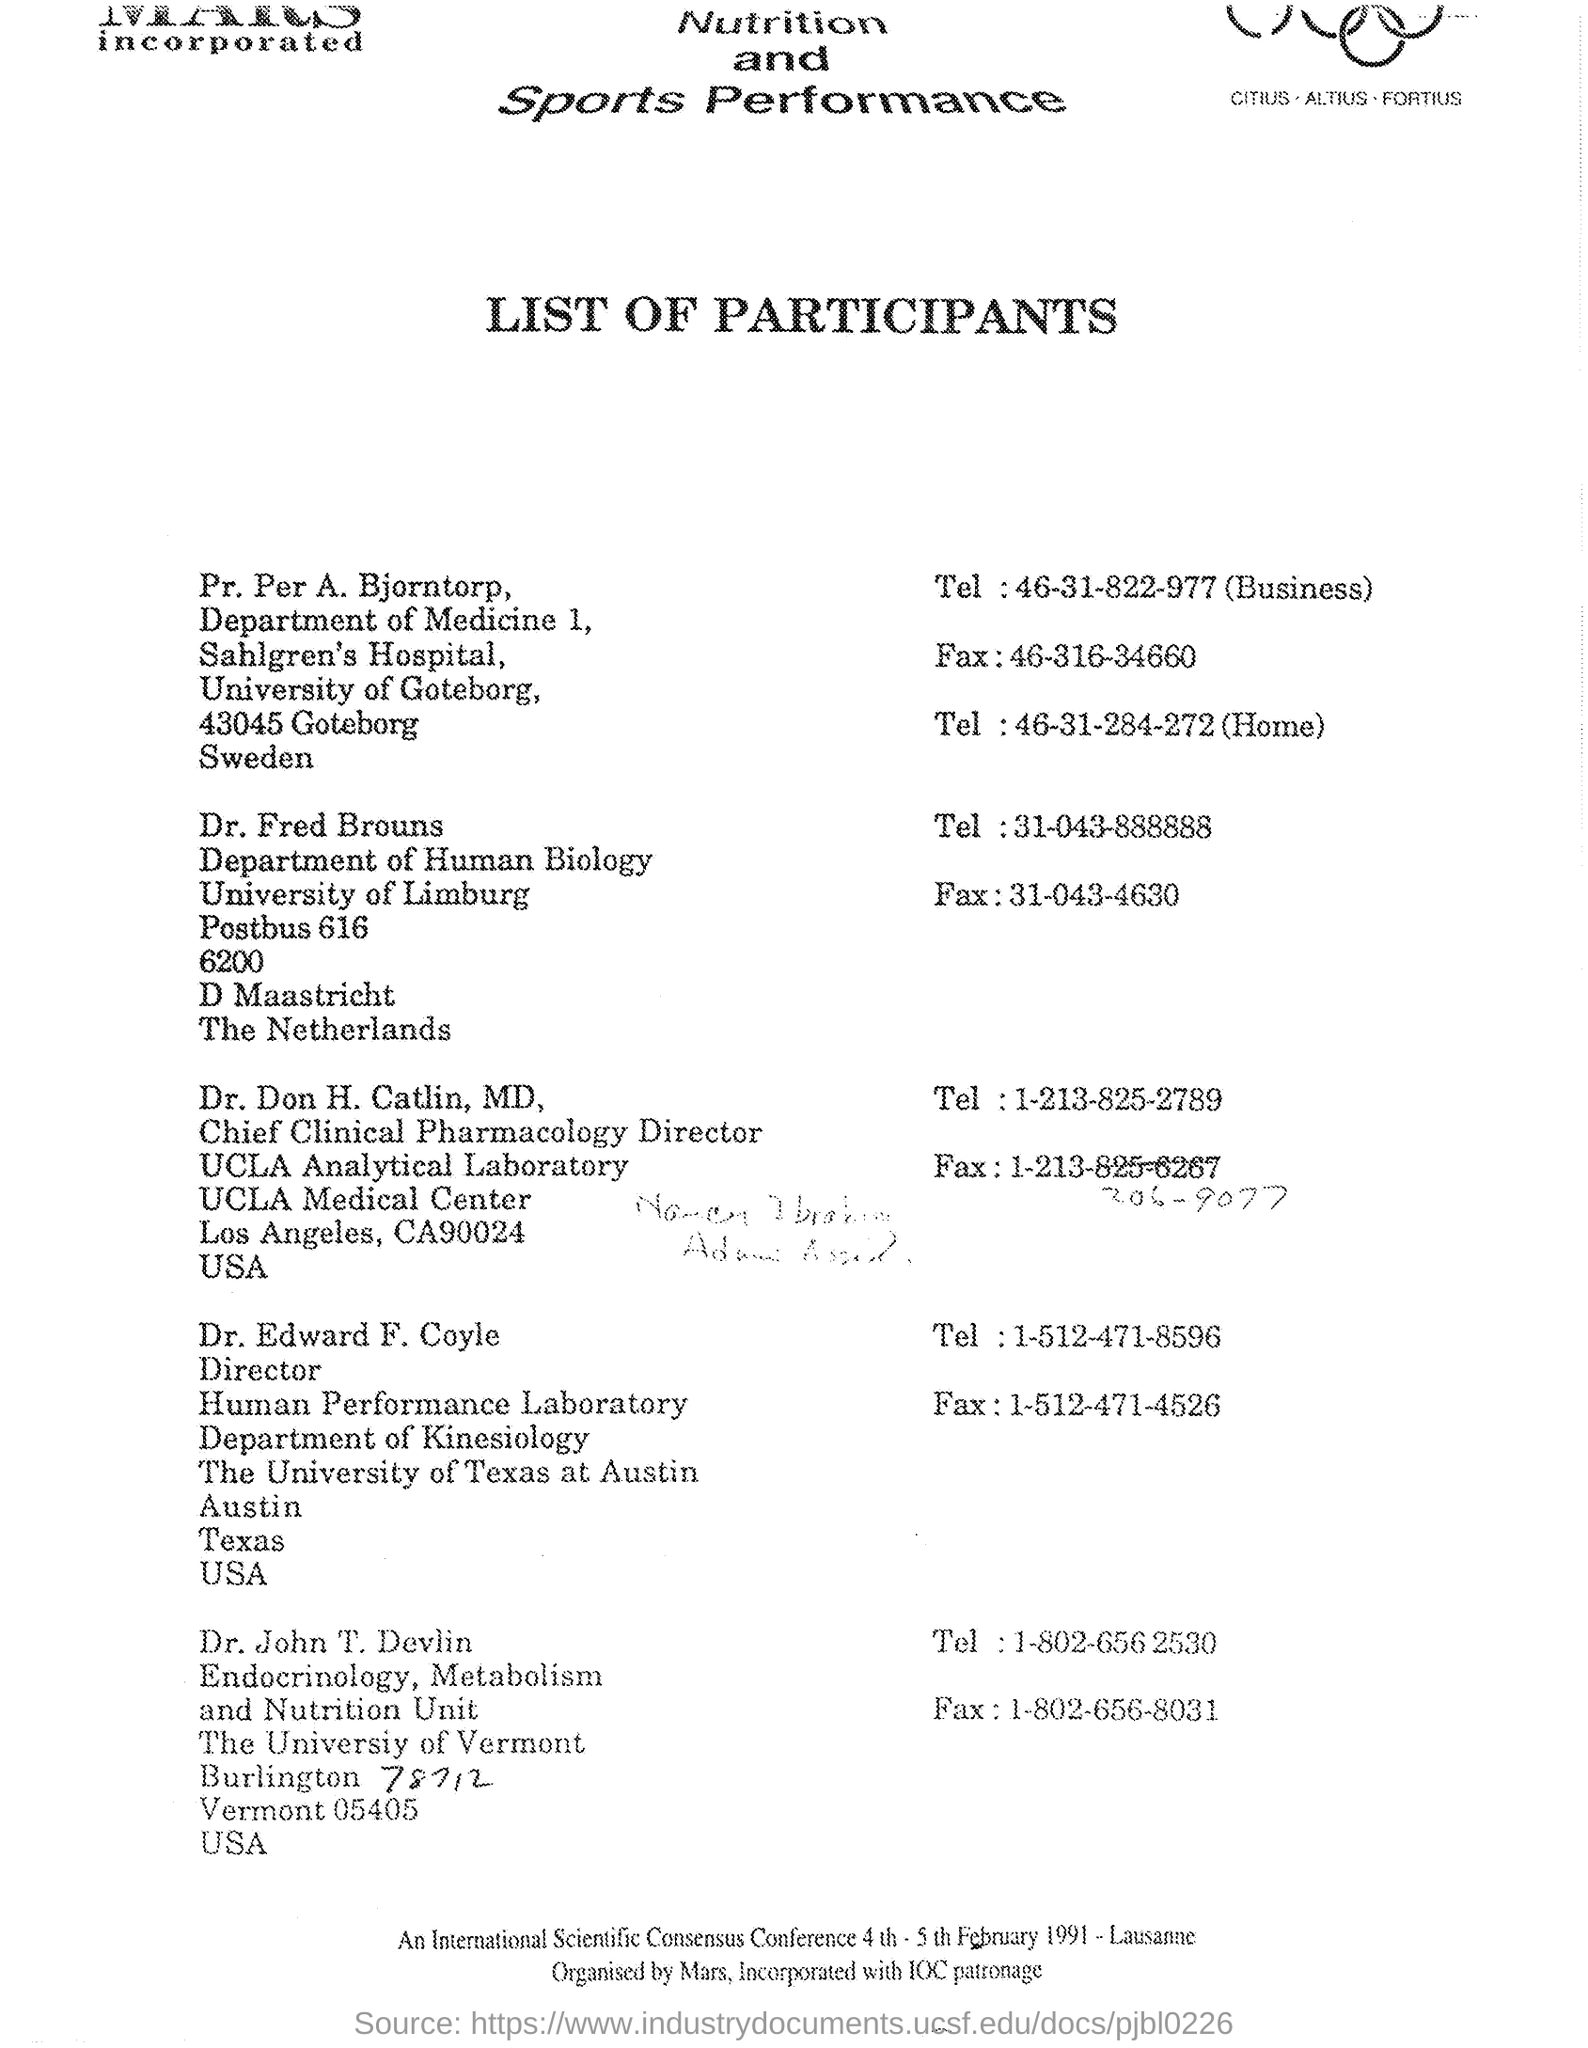To which department pr. per a. bjorntorp belongs to ?
Your answer should be very brief. Department of Medicine 1. To which university pr. per a. bjorntorp belongs to ?/
Offer a terse response. University Of Goteborg. What is the name of the department of dr. fred brouns ?
Make the answer very short. Department of human biology. What is the name of the university of dr. fred brouns ?
Make the answer very short. University of Limburg. What is the tel: no. given for dr. fred brouns ?
Provide a succinct answer. 31-043-888888. What is the designation of dr. edward f. coyle ?
Your answer should be compact. Director. To which department dr. edward f. coyle belongs to ?
Provide a short and direct response. Department of Kinesiology. To which university dr. edward f. coyle belongs to ?
Your response must be concise. The university of texas at Austin. To which university dr. john t. devlin belongs to ?
Provide a succinct answer. The university of Vermont. 